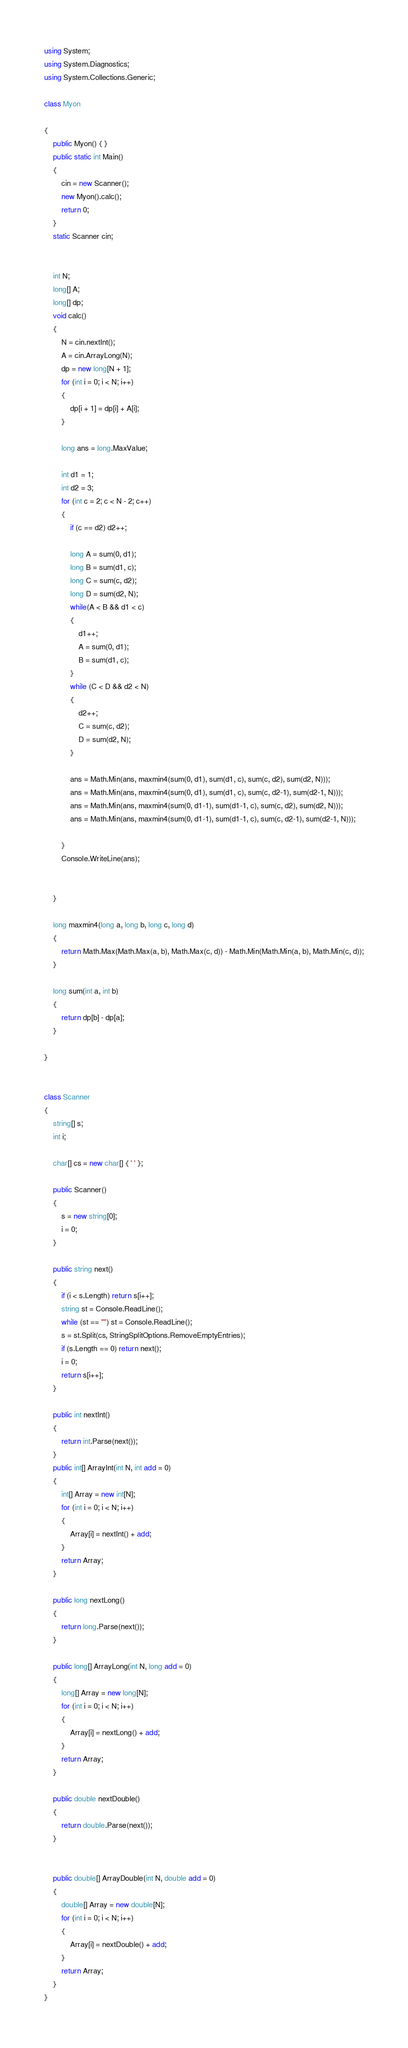<code> <loc_0><loc_0><loc_500><loc_500><_C#_>using System;
using System.Diagnostics;
using System.Collections.Generic;

class Myon

{
    public Myon() { }
    public static int Main()
    {
        cin = new Scanner();
        new Myon().calc();
        return 0;
    }
    static Scanner cin;


    int N;
    long[] A;
    long[] dp;
    void calc()
    {
        N = cin.nextInt();
        A = cin.ArrayLong(N);
        dp = new long[N + 1];
        for (int i = 0; i < N; i++)
        {
            dp[i + 1] = dp[i] + A[i];
        }

        long ans = long.MaxValue;

        int d1 = 1;
        int d2 = 3;
        for (int c = 2; c < N - 2; c++)
        {
            if (c == d2) d2++;

            long A = sum(0, d1);
            long B = sum(d1, c);
            long C = sum(c, d2);
            long D = sum(d2, N);
            while(A < B && d1 < c)
            {
                d1++;
                A = sum(0, d1);
                B = sum(d1, c);
            }
            while (C < D && d2 < N)
            {
                d2++;
                C = sum(c, d2);
                D = sum(d2, N);
            }

            ans = Math.Min(ans, maxmin4(sum(0, d1), sum(d1, c), sum(c, d2), sum(d2, N)));
            ans = Math.Min(ans, maxmin4(sum(0, d1), sum(d1, c), sum(c, d2-1), sum(d2-1, N)));
            ans = Math.Min(ans, maxmin4(sum(0, d1-1), sum(d1-1, c), sum(c, d2), sum(d2, N)));
            ans = Math.Min(ans, maxmin4(sum(0, d1-1), sum(d1-1, c), sum(c, d2-1), sum(d2-1, N)));

        }
        Console.WriteLine(ans);


    }

    long maxmin4(long a, long b, long c, long d)
    {
        return Math.Max(Math.Max(a, b), Math.Max(c, d)) - Math.Min(Math.Min(a, b), Math.Min(c, d));
    }

    long sum(int a, int b)
    {
        return dp[b] - dp[a];
    }
    
}


class Scanner
{
    string[] s;
    int i;

    char[] cs = new char[] { ' ' };

    public Scanner()
    {
        s = new string[0];
        i = 0;
    }

    public string next()
    {
        if (i < s.Length) return s[i++];
        string st = Console.ReadLine();
        while (st == "") st = Console.ReadLine();
        s = st.Split(cs, StringSplitOptions.RemoveEmptyEntries);
        if (s.Length == 0) return next();
        i = 0;
        return s[i++];
    }

    public int nextInt()
    {
        return int.Parse(next());
    }
    public int[] ArrayInt(int N, int add = 0)
    {
        int[] Array = new int[N];
        for (int i = 0; i < N; i++)
        {
            Array[i] = nextInt() + add;
        }
        return Array;
    }

    public long nextLong()
    {
        return long.Parse(next());
    }

    public long[] ArrayLong(int N, long add = 0)
    {
        long[] Array = new long[N];
        for (int i = 0; i < N; i++)
        {
            Array[i] = nextLong() + add;
        }
        return Array;
    }

    public double nextDouble()
    {
        return double.Parse(next());
    }


    public double[] ArrayDouble(int N, double add = 0)
    {
        double[] Array = new double[N];
        for (int i = 0; i < N; i++)
        {
            Array[i] = nextDouble() + add;
        }
        return Array;
    }
}


</code> 